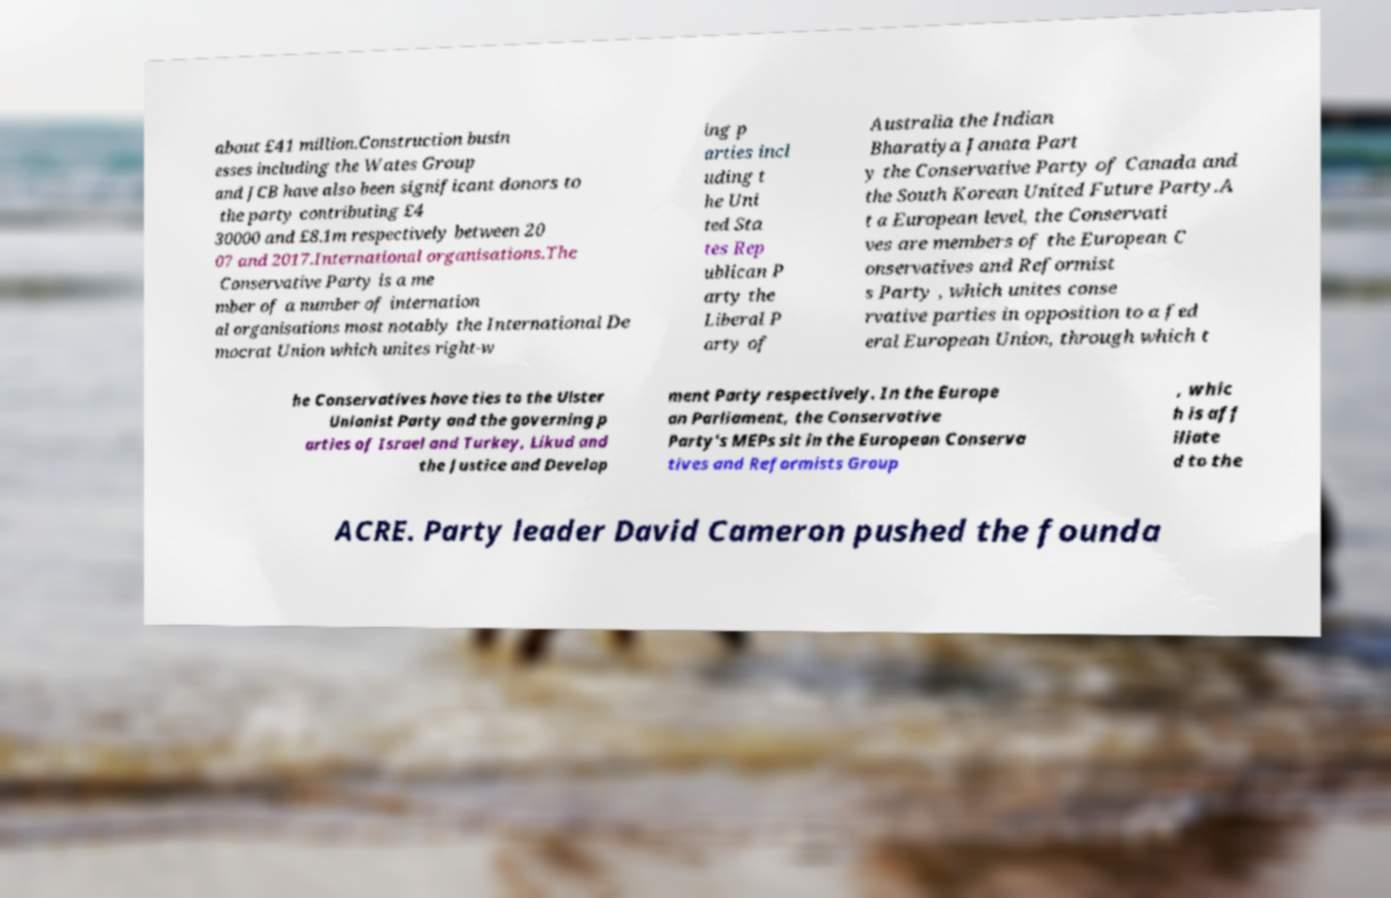For documentation purposes, I need the text within this image transcribed. Could you provide that? about £41 million.Construction busin esses including the Wates Group and JCB have also been significant donors to the party contributing £4 30000 and £8.1m respectively between 20 07 and 2017.International organisations.The Conservative Party is a me mber of a number of internation al organisations most notably the International De mocrat Union which unites right-w ing p arties incl uding t he Uni ted Sta tes Rep ublican P arty the Liberal P arty of Australia the Indian Bharatiya Janata Part y the Conservative Party of Canada and the South Korean United Future Party.A t a European level, the Conservati ves are members of the European C onservatives and Reformist s Party , which unites conse rvative parties in opposition to a fed eral European Union, through which t he Conservatives have ties to the Ulster Unionist Party and the governing p arties of Israel and Turkey, Likud and the Justice and Develop ment Party respectively. In the Europe an Parliament, the Conservative Party's MEPs sit in the European Conserva tives and Reformists Group , whic h is aff iliate d to the ACRE. Party leader David Cameron pushed the founda 